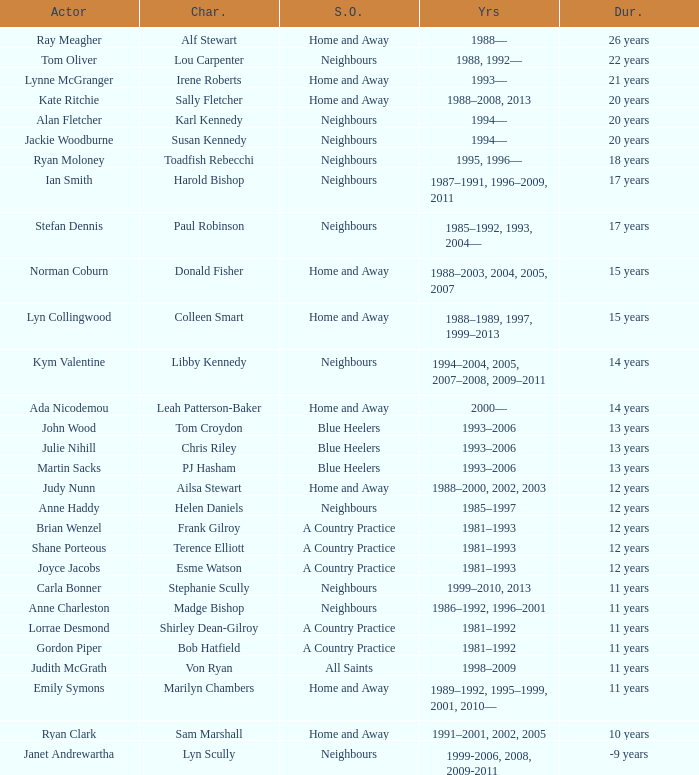What character was portrayed by the same actor for 12 years on Neighbours? Helen Daniels. 